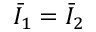<formula> <loc_0><loc_0><loc_500><loc_500>{ \bar { I } } _ { 1 } = { \bar { I } } _ { 2 }</formula> 